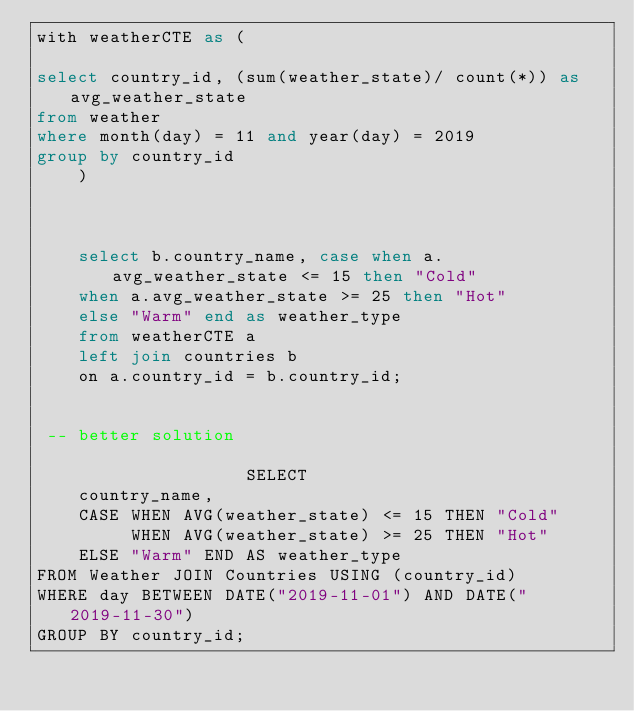Convert code to text. <code><loc_0><loc_0><loc_500><loc_500><_SQL_>with weatherCTE as (

select country_id, (sum(weather_state)/ count(*)) as avg_weather_state
from weather
where month(day) = 11 and year(day) = 2019
group by country_id
    )
    
    
    
    select b.country_name, case when a.avg_weather_state <= 15 then "Cold"
    when a.avg_weather_state >= 25 then "Hot" 
    else "Warm" end as weather_type
    from weatherCTE a
    left join countries b
    on a.country_id = b.country_id;

                    
 -- better solution
                    
                    SELECT 
    country_name, 
    CASE WHEN AVG(weather_state) <= 15 THEN "Cold"
         WHEN AVG(weather_state) >= 25 THEN "Hot"
    ELSE "Warm" END AS weather_type
FROM Weather JOIN Countries USING (country_id)
WHERE day BETWEEN DATE("2019-11-01") AND DATE("2019-11-30")
GROUP BY country_id; 
</code> 